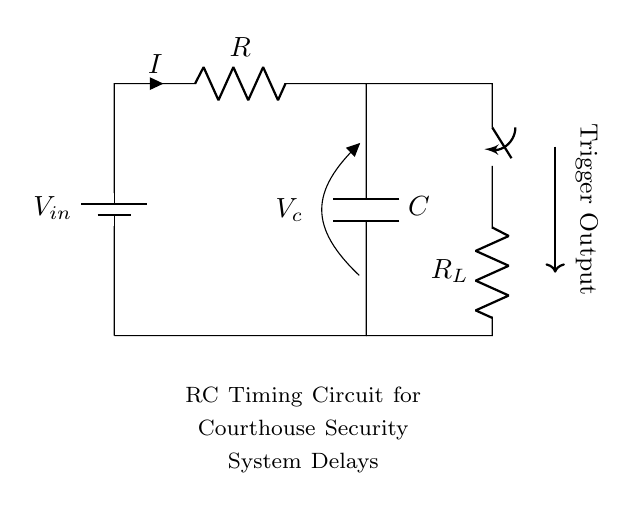What is the type of the primary circuit component? The primary circuit component in this diagram is a resistor, indicated by the symbol and labeled as R. Resistors are used to limit current flow in a circuit.
Answer: Resistor What is the value of the capacitor? The value of the capacitor is denoted by C in the diagram. There are no numerical values specified, but it represents the capacitance of the capacitor in the circuit.
Answer: C What is the role of the switch in this circuit? The switch allows the user to control the flow of current in the circuit. When closed, it enables current to pass through the resistor and capacitor, influencing the timing delay of the security system.
Answer: Control Which component is responsible for voltage drop? The resistor is responsible for the voltage drop in the circuit. According to Ohm's Law, voltage across a resistor is directly proportional to the current flowing through it, which creates a voltage drop.
Answer: Resistor When the switch is closed, what happens to the voltage across the capacitor? When the switch is closed, the capacitor begins to charge through the resistor, causing the voltage across it to increase exponentially until it reaches the input voltage. This behavior is characteristic of RC timing circuits.
Answer: Increases What is the time constant for this RC circuit? The time constant is determined by the values of the resistor and the capacitor, represented as τ = R * C. This time constant defines how quickly the capacitor charges or discharges in the circuit.
Answer: R * C How does this circuit contribute to the courthouse security system? This RC timing circuit introduces a delay in the triggering of alarms or security measures, allowing a brief moment to cancel potential false alarms or provide a grace period for authorized individuals.
Answer: Delay 